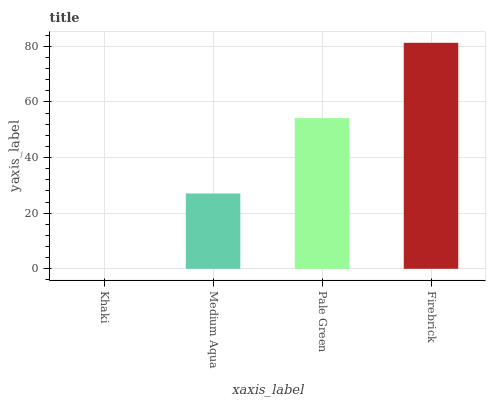Is Medium Aqua the minimum?
Answer yes or no. No. Is Medium Aqua the maximum?
Answer yes or no. No. Is Medium Aqua greater than Khaki?
Answer yes or no. Yes. Is Khaki less than Medium Aqua?
Answer yes or no. Yes. Is Khaki greater than Medium Aqua?
Answer yes or no. No. Is Medium Aqua less than Khaki?
Answer yes or no. No. Is Pale Green the high median?
Answer yes or no. Yes. Is Medium Aqua the low median?
Answer yes or no. Yes. Is Firebrick the high median?
Answer yes or no. No. Is Firebrick the low median?
Answer yes or no. No. 